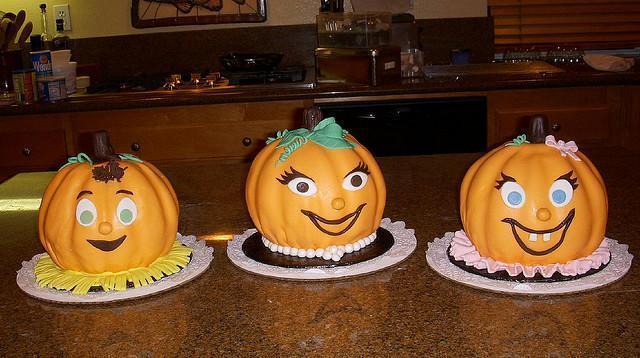How many cakes are in the photo?
Give a very brief answer. 3. 